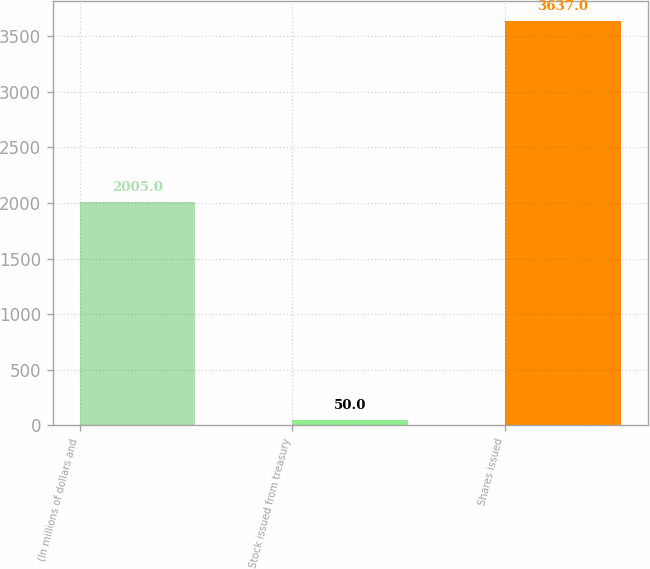Convert chart to OTSL. <chart><loc_0><loc_0><loc_500><loc_500><bar_chart><fcel>(In millions of dollars and<fcel>Stock issued from treasury<fcel>Shares issued<nl><fcel>2005<fcel>50<fcel>3637<nl></chart> 